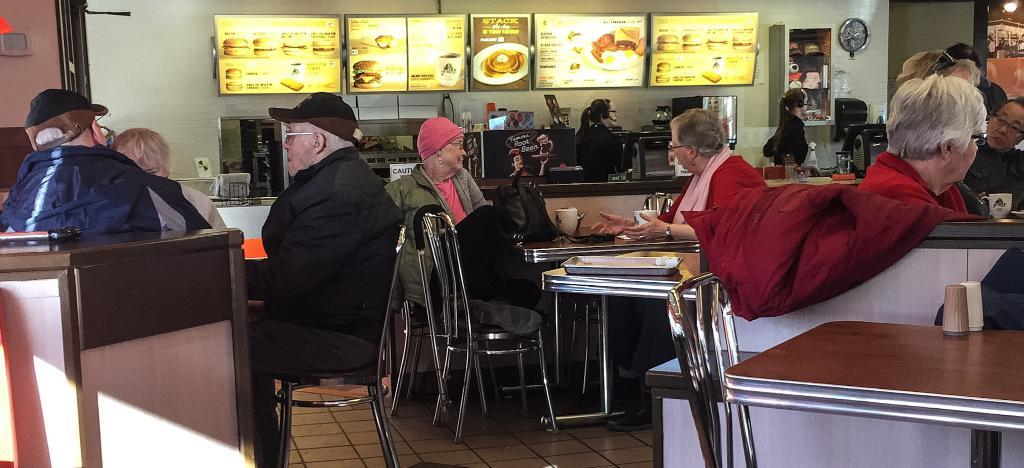Where was the image taken? The image was taken inside a restaurant. What can be seen at the tables in the image? There are people sitting at tables in the image. What is displayed on the monitors in the background? The monitors display a liquid menu. What type of help can be seen being offered in the image? There is no help being offered in the image; it only shows people sitting at tables and monitors displaying a liquid menu. 